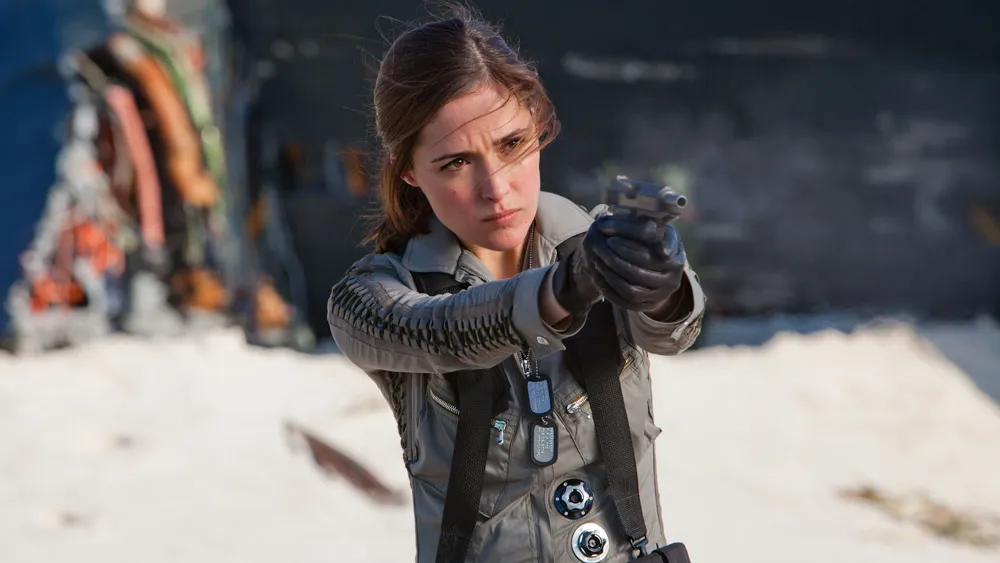Describe the possible futuristic elements in the character’s outfit. The character's outfit features several futuristic elements that suggest advanced technology and specialized design. The jacket is adorned with intricate metallic accents and patterns, likely serving both aesthetic and functional purposes. The black harness she wears could be integrated with various technological devices, such as communication tools, sensors for environmental analysis, or enhanced mobility aids. The gloves might be equipped with tactical enhancements, allowing for improved grip and possibly even augmented physical strength. The overall design of the outfit merges sleekness with practicality, indicative of a future where fashion and function harmoniously coexist in tactical gear. What could be the significance of the gun she’s holding in this futuristic setting? In this futuristic setting, the gun she’s holding might be a highly advanced weapon, far beyond conventional firearms. It could be equipped with adaptive ammunition, capable of changing its properties based on the situation or target. The gun might also feature smart targeting systems, integrating with her visor or contact lenses to provide real-time aiming assistance, greatly improving accuracy and response time. Additionally, the weapon could have biometric security, ensuring that only she can operate it. This level of technology suggests an era where personal weaponry is immensely sophisticated, essential for navigating the high-stakes environments characters like her face. Imagine she’s a character in a post-apocalyptic world. What does her gear tell us about her survival strategy? In a post-apocalyptic world, her gear speaks volumes about her survival strategy. The detailed gray jacket with its durable material and metallic accents indicates it’s designed to offer maximum protection against various threats, whether they be environmental hazards or hostile encounters. The black harness suggests she carries essential supplies and tools needed for survival, likely including medical kits, food, and other necessary equipment. The gloves protect her hands from extreme conditions and provide a secure grip on her weapon. Her determined expression and the high-tech gun imply she’s ready to defend herself and possibly others, showcasing a blend of caution, preparedness, and resilience essential for thriving in such a harsh landscape. 